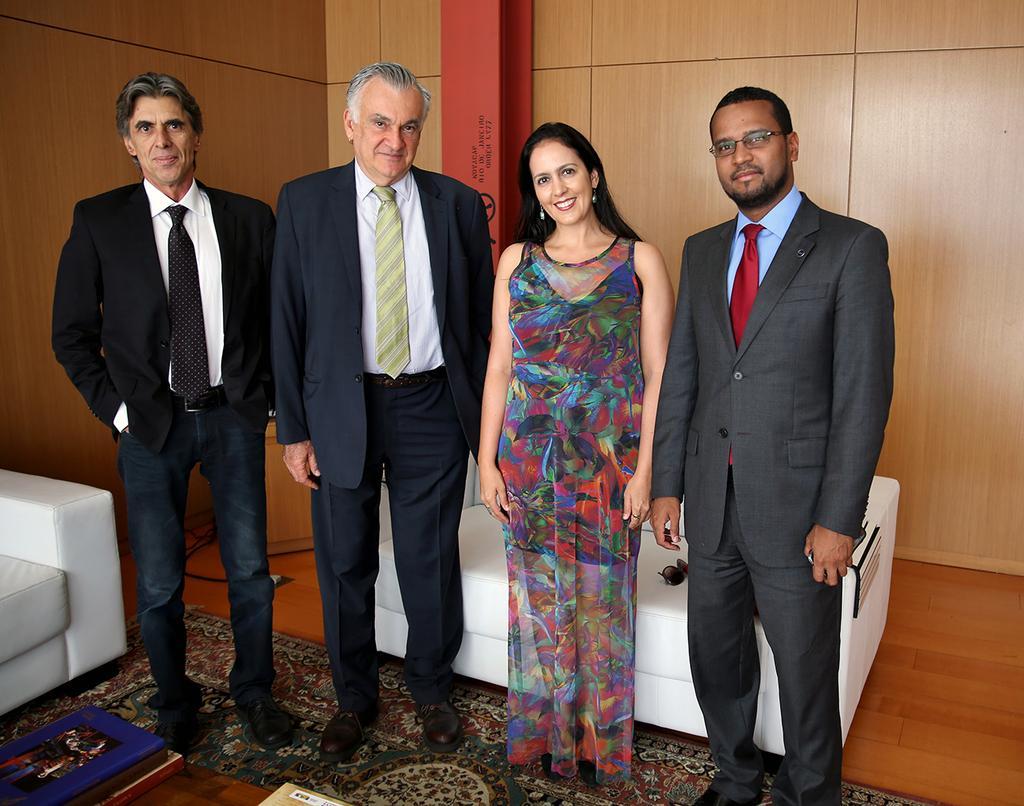In one or two sentences, can you explain what this image depicts? In this image, we can see people standing and in the background, there are sofas and there is a wall. At the bottom, there is carpet. 